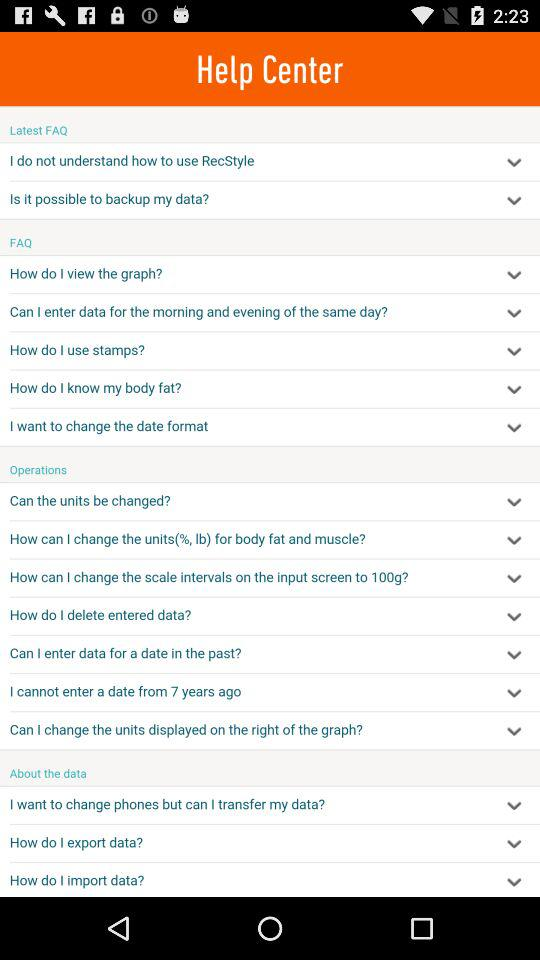What are the latest FAQs? The latest FAQs are "I do not understand how to use RecStyle" and "Is it possible to backup my data?". 